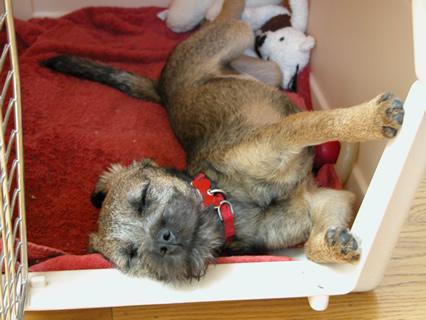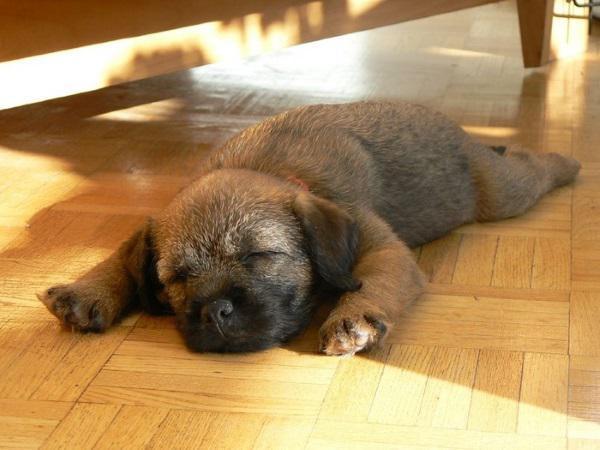The first image is the image on the left, the second image is the image on the right. Evaluate the accuracy of this statement regarding the images: "One dog is sleeping directly on a hard, wood-look floor.". Is it true? Answer yes or no. Yes. The first image is the image on the left, the second image is the image on the right. Analyze the images presented: Is the assertion "A puppy is asleep on a wooden floor." valid? Answer yes or no. Yes. 